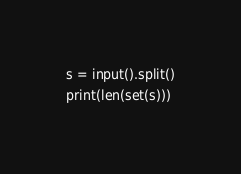<code> <loc_0><loc_0><loc_500><loc_500><_Python_>s = input().split()
print(len(set(s)))
</code> 